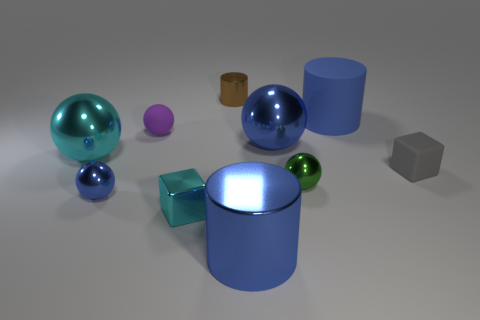Subtract all green metallic spheres. How many spheres are left? 4 Subtract all brown cylinders. How many blue spheres are left? 2 Subtract all cyan spheres. How many spheres are left? 4 Subtract all cubes. How many objects are left? 8 Subtract all green cylinders. Subtract all yellow cubes. How many cylinders are left? 3 Subtract all gray rubber objects. Subtract all small matte things. How many objects are left? 7 Add 1 cyan spheres. How many cyan spheres are left? 2 Add 10 tiny yellow things. How many tiny yellow things exist? 10 Subtract 0 purple cubes. How many objects are left? 10 